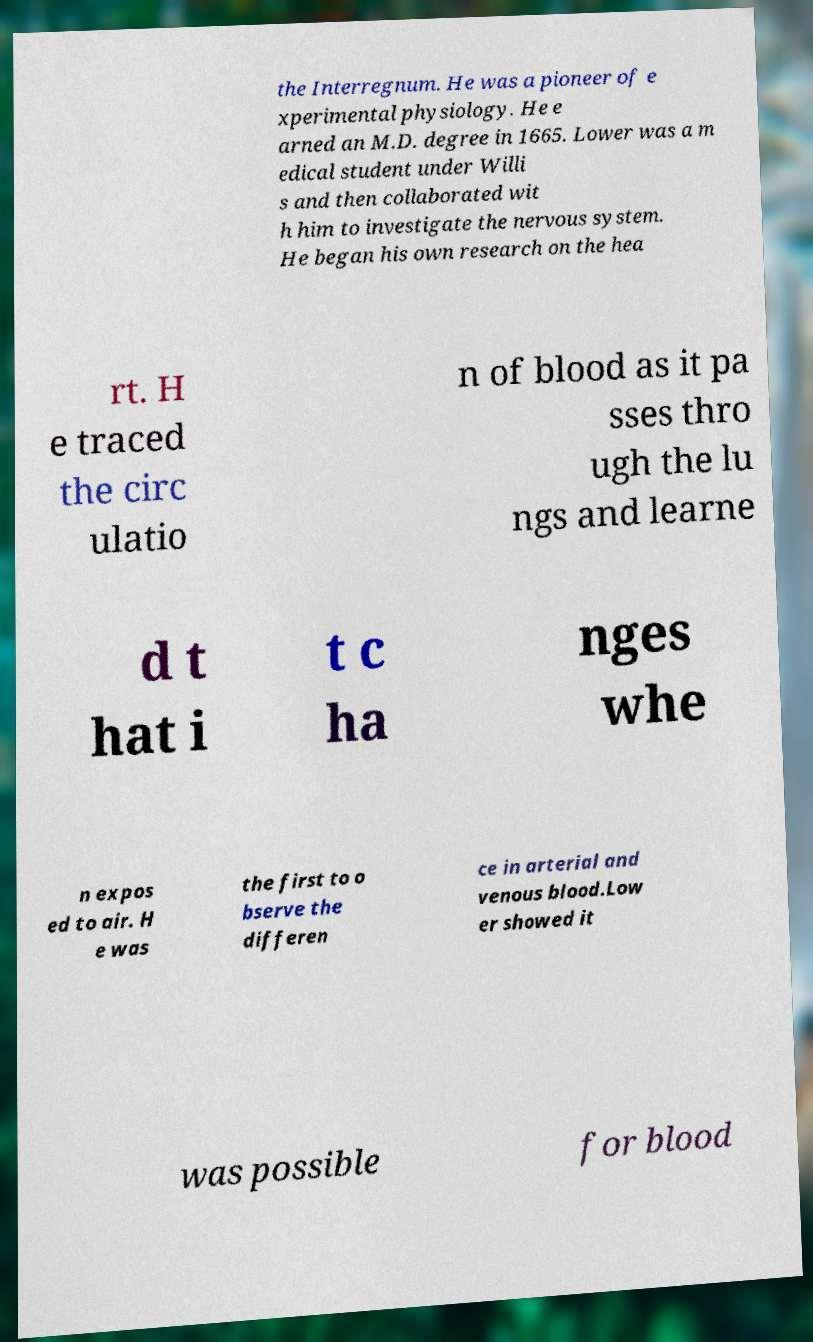I need the written content from this picture converted into text. Can you do that? the Interregnum. He was a pioneer of e xperimental physiology. He e arned an M.D. degree in 1665. Lower was a m edical student under Willi s and then collaborated wit h him to investigate the nervous system. He began his own research on the hea rt. H e traced the circ ulatio n of blood as it pa sses thro ugh the lu ngs and learne d t hat i t c ha nges whe n expos ed to air. H e was the first to o bserve the differen ce in arterial and venous blood.Low er showed it was possible for blood 